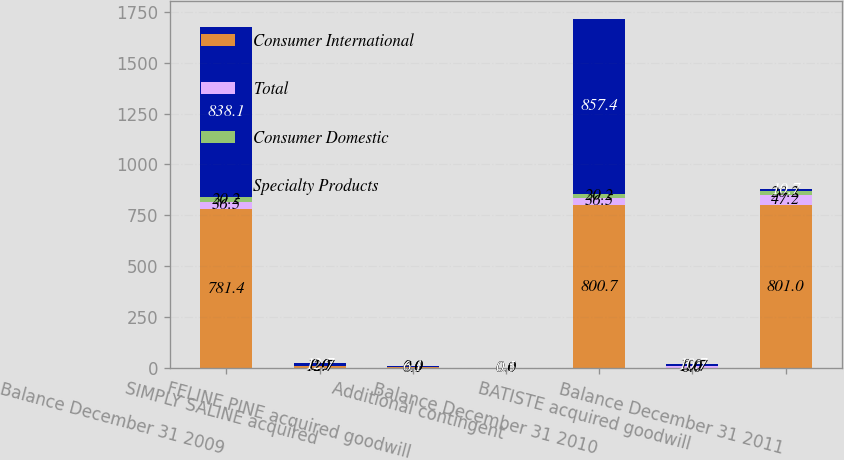Convert chart to OTSL. <chart><loc_0><loc_0><loc_500><loc_500><stacked_bar_chart><ecel><fcel>Balance December 31 2009<fcel>SIMPLY SALINE acquired<fcel>FELINE PINE acquired goodwill<fcel>Additional contingent<fcel>Balance December 31 2010<fcel>BATISTE acquired goodwill<fcel>Balance December 31 2011<nl><fcel>Consumer International<fcel>781.4<fcel>12.7<fcel>6.1<fcel>0.5<fcel>800.7<fcel>0<fcel>801<nl><fcel>Total<fcel>36.5<fcel>0<fcel>0<fcel>0<fcel>36.5<fcel>10.7<fcel>47.2<nl><fcel>Consumer Domestic<fcel>20.2<fcel>0<fcel>0<fcel>0<fcel>20.2<fcel>0<fcel>20.2<nl><fcel>Specialty Products<fcel>838.1<fcel>12.7<fcel>6.1<fcel>0.5<fcel>857.4<fcel>10.7<fcel>10.7<nl></chart> 